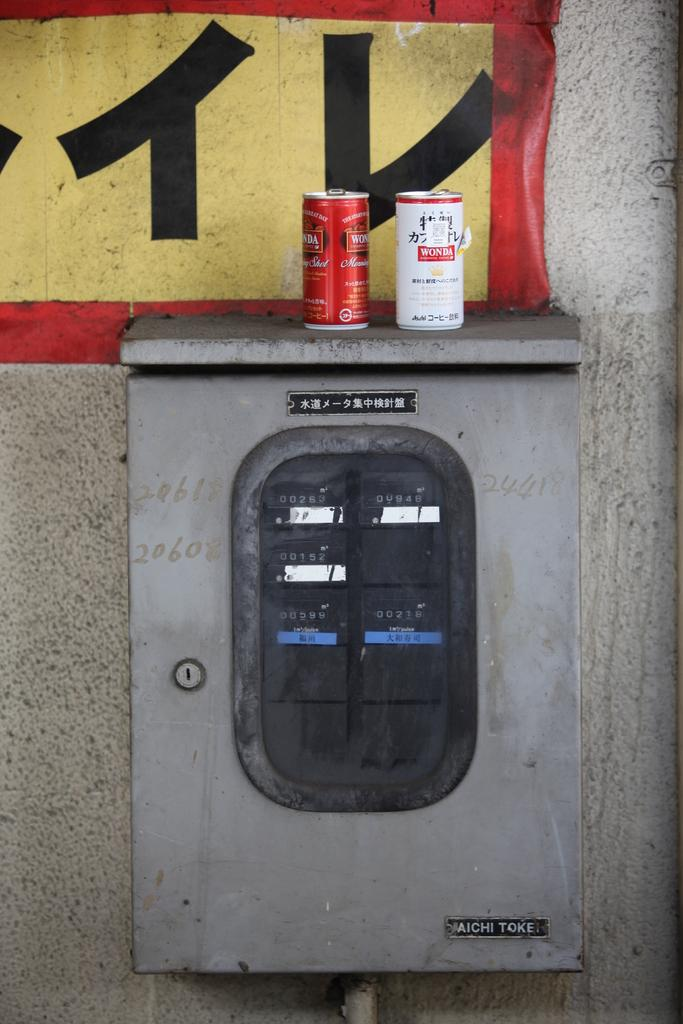<image>
Offer a succinct explanation of the picture presented. Two cans of Wonda, one red and one white, sit on a utility box. 